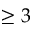<formula> <loc_0><loc_0><loc_500><loc_500>\geq 3</formula> 